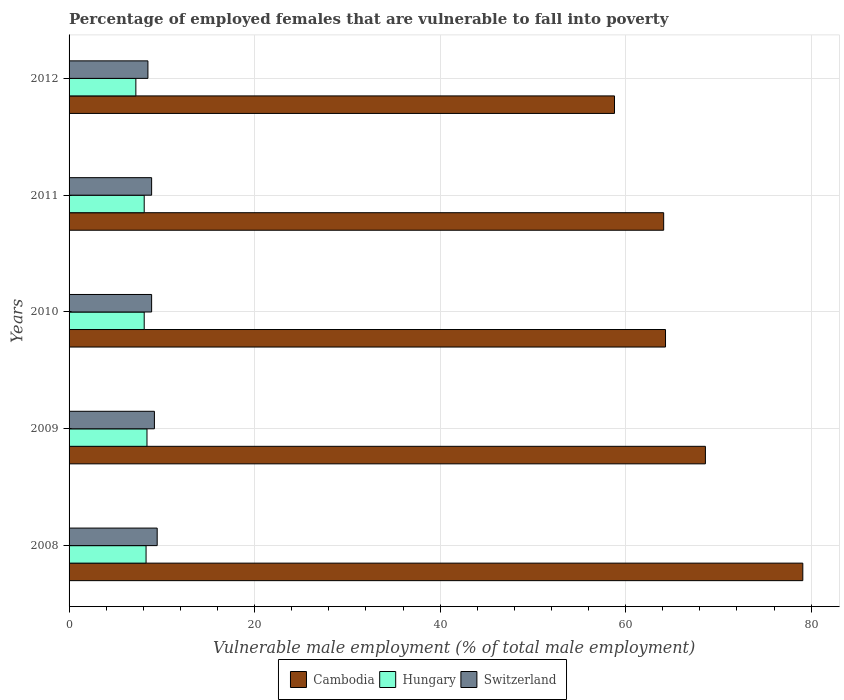How many groups of bars are there?
Provide a short and direct response. 5. How many bars are there on the 5th tick from the top?
Provide a succinct answer. 3. What is the label of the 5th group of bars from the top?
Offer a terse response. 2008. In how many cases, is the number of bars for a given year not equal to the number of legend labels?
Offer a very short reply. 0. What is the percentage of employed females who are vulnerable to fall into poverty in Cambodia in 2012?
Keep it short and to the point. 58.8. Across all years, what is the minimum percentage of employed females who are vulnerable to fall into poverty in Hungary?
Keep it short and to the point. 7.2. What is the total percentage of employed females who are vulnerable to fall into poverty in Switzerland in the graph?
Your answer should be compact. 45. What is the difference between the percentage of employed females who are vulnerable to fall into poverty in Hungary in 2008 and that in 2012?
Ensure brevity in your answer.  1.1. What is the difference between the percentage of employed females who are vulnerable to fall into poverty in Cambodia in 2009 and the percentage of employed females who are vulnerable to fall into poverty in Switzerland in 2012?
Offer a terse response. 60.1. What is the average percentage of employed females who are vulnerable to fall into poverty in Hungary per year?
Keep it short and to the point. 8.02. In the year 2012, what is the difference between the percentage of employed females who are vulnerable to fall into poverty in Cambodia and percentage of employed females who are vulnerable to fall into poverty in Hungary?
Offer a terse response. 51.6. In how many years, is the percentage of employed females who are vulnerable to fall into poverty in Cambodia greater than 16 %?
Ensure brevity in your answer.  5. What is the ratio of the percentage of employed females who are vulnerable to fall into poverty in Cambodia in 2011 to that in 2012?
Provide a short and direct response. 1.09. Is the percentage of employed females who are vulnerable to fall into poverty in Cambodia in 2009 less than that in 2010?
Your answer should be very brief. No. What is the difference between the highest and the second highest percentage of employed females who are vulnerable to fall into poverty in Switzerland?
Your answer should be compact. 0.3. In how many years, is the percentage of employed females who are vulnerable to fall into poverty in Hungary greater than the average percentage of employed females who are vulnerable to fall into poverty in Hungary taken over all years?
Provide a short and direct response. 4. Is the sum of the percentage of employed females who are vulnerable to fall into poverty in Cambodia in 2011 and 2012 greater than the maximum percentage of employed females who are vulnerable to fall into poverty in Switzerland across all years?
Your response must be concise. Yes. What does the 3rd bar from the top in 2011 represents?
Provide a succinct answer. Cambodia. What does the 1st bar from the bottom in 2009 represents?
Keep it short and to the point. Cambodia. How many bars are there?
Your response must be concise. 15. How many years are there in the graph?
Keep it short and to the point. 5. What is the difference between two consecutive major ticks on the X-axis?
Provide a succinct answer. 20. Are the values on the major ticks of X-axis written in scientific E-notation?
Keep it short and to the point. No. Does the graph contain any zero values?
Your response must be concise. No. Does the graph contain grids?
Ensure brevity in your answer.  Yes. Where does the legend appear in the graph?
Your response must be concise. Bottom center. How are the legend labels stacked?
Offer a very short reply. Horizontal. What is the title of the graph?
Ensure brevity in your answer.  Percentage of employed females that are vulnerable to fall into poverty. Does "Liechtenstein" appear as one of the legend labels in the graph?
Provide a succinct answer. No. What is the label or title of the X-axis?
Your answer should be compact. Vulnerable male employment (% of total male employment). What is the label or title of the Y-axis?
Keep it short and to the point. Years. What is the Vulnerable male employment (% of total male employment) of Cambodia in 2008?
Your answer should be compact. 79.1. What is the Vulnerable male employment (% of total male employment) in Hungary in 2008?
Give a very brief answer. 8.3. What is the Vulnerable male employment (% of total male employment) of Switzerland in 2008?
Give a very brief answer. 9.5. What is the Vulnerable male employment (% of total male employment) of Cambodia in 2009?
Offer a terse response. 68.6. What is the Vulnerable male employment (% of total male employment) of Hungary in 2009?
Provide a succinct answer. 8.4. What is the Vulnerable male employment (% of total male employment) of Switzerland in 2009?
Your answer should be very brief. 9.2. What is the Vulnerable male employment (% of total male employment) of Cambodia in 2010?
Give a very brief answer. 64.3. What is the Vulnerable male employment (% of total male employment) in Hungary in 2010?
Provide a succinct answer. 8.1. What is the Vulnerable male employment (% of total male employment) in Switzerland in 2010?
Offer a very short reply. 8.9. What is the Vulnerable male employment (% of total male employment) in Cambodia in 2011?
Make the answer very short. 64.1. What is the Vulnerable male employment (% of total male employment) in Hungary in 2011?
Make the answer very short. 8.1. What is the Vulnerable male employment (% of total male employment) in Switzerland in 2011?
Offer a terse response. 8.9. What is the Vulnerable male employment (% of total male employment) of Cambodia in 2012?
Your answer should be compact. 58.8. What is the Vulnerable male employment (% of total male employment) of Hungary in 2012?
Your answer should be compact. 7.2. Across all years, what is the maximum Vulnerable male employment (% of total male employment) in Cambodia?
Ensure brevity in your answer.  79.1. Across all years, what is the maximum Vulnerable male employment (% of total male employment) in Hungary?
Give a very brief answer. 8.4. Across all years, what is the maximum Vulnerable male employment (% of total male employment) of Switzerland?
Your answer should be compact. 9.5. Across all years, what is the minimum Vulnerable male employment (% of total male employment) of Cambodia?
Offer a very short reply. 58.8. Across all years, what is the minimum Vulnerable male employment (% of total male employment) in Hungary?
Give a very brief answer. 7.2. Across all years, what is the minimum Vulnerable male employment (% of total male employment) of Switzerland?
Provide a succinct answer. 8.5. What is the total Vulnerable male employment (% of total male employment) in Cambodia in the graph?
Offer a terse response. 334.9. What is the total Vulnerable male employment (% of total male employment) in Hungary in the graph?
Offer a very short reply. 40.1. What is the difference between the Vulnerable male employment (% of total male employment) in Switzerland in 2008 and that in 2009?
Keep it short and to the point. 0.3. What is the difference between the Vulnerable male employment (% of total male employment) of Cambodia in 2008 and that in 2010?
Your answer should be compact. 14.8. What is the difference between the Vulnerable male employment (% of total male employment) of Cambodia in 2008 and that in 2012?
Your answer should be compact. 20.3. What is the difference between the Vulnerable male employment (% of total male employment) in Hungary in 2008 and that in 2012?
Make the answer very short. 1.1. What is the difference between the Vulnerable male employment (% of total male employment) in Switzerland in 2008 and that in 2012?
Your answer should be very brief. 1. What is the difference between the Vulnerable male employment (% of total male employment) in Cambodia in 2009 and that in 2010?
Your answer should be compact. 4.3. What is the difference between the Vulnerable male employment (% of total male employment) in Cambodia in 2009 and that in 2011?
Give a very brief answer. 4.5. What is the difference between the Vulnerable male employment (% of total male employment) in Hungary in 2009 and that in 2011?
Ensure brevity in your answer.  0.3. What is the difference between the Vulnerable male employment (% of total male employment) in Cambodia in 2009 and that in 2012?
Offer a very short reply. 9.8. What is the difference between the Vulnerable male employment (% of total male employment) of Hungary in 2009 and that in 2012?
Keep it short and to the point. 1.2. What is the difference between the Vulnerable male employment (% of total male employment) of Switzerland in 2010 and that in 2011?
Provide a succinct answer. 0. What is the difference between the Vulnerable male employment (% of total male employment) in Hungary in 2010 and that in 2012?
Your answer should be very brief. 0.9. What is the difference between the Vulnerable male employment (% of total male employment) of Switzerland in 2010 and that in 2012?
Your answer should be compact. 0.4. What is the difference between the Vulnerable male employment (% of total male employment) in Hungary in 2011 and that in 2012?
Your response must be concise. 0.9. What is the difference between the Vulnerable male employment (% of total male employment) in Cambodia in 2008 and the Vulnerable male employment (% of total male employment) in Hungary in 2009?
Give a very brief answer. 70.7. What is the difference between the Vulnerable male employment (% of total male employment) of Cambodia in 2008 and the Vulnerable male employment (% of total male employment) of Switzerland in 2009?
Offer a terse response. 69.9. What is the difference between the Vulnerable male employment (% of total male employment) in Hungary in 2008 and the Vulnerable male employment (% of total male employment) in Switzerland in 2009?
Your answer should be compact. -0.9. What is the difference between the Vulnerable male employment (% of total male employment) of Cambodia in 2008 and the Vulnerable male employment (% of total male employment) of Switzerland in 2010?
Offer a terse response. 70.2. What is the difference between the Vulnerable male employment (% of total male employment) of Hungary in 2008 and the Vulnerable male employment (% of total male employment) of Switzerland in 2010?
Your answer should be very brief. -0.6. What is the difference between the Vulnerable male employment (% of total male employment) in Cambodia in 2008 and the Vulnerable male employment (% of total male employment) in Hungary in 2011?
Offer a terse response. 71. What is the difference between the Vulnerable male employment (% of total male employment) in Cambodia in 2008 and the Vulnerable male employment (% of total male employment) in Switzerland in 2011?
Your answer should be compact. 70.2. What is the difference between the Vulnerable male employment (% of total male employment) in Cambodia in 2008 and the Vulnerable male employment (% of total male employment) in Hungary in 2012?
Your answer should be very brief. 71.9. What is the difference between the Vulnerable male employment (% of total male employment) in Cambodia in 2008 and the Vulnerable male employment (% of total male employment) in Switzerland in 2012?
Provide a succinct answer. 70.6. What is the difference between the Vulnerable male employment (% of total male employment) in Hungary in 2008 and the Vulnerable male employment (% of total male employment) in Switzerland in 2012?
Provide a succinct answer. -0.2. What is the difference between the Vulnerable male employment (% of total male employment) of Cambodia in 2009 and the Vulnerable male employment (% of total male employment) of Hungary in 2010?
Your response must be concise. 60.5. What is the difference between the Vulnerable male employment (% of total male employment) of Cambodia in 2009 and the Vulnerable male employment (% of total male employment) of Switzerland in 2010?
Offer a very short reply. 59.7. What is the difference between the Vulnerable male employment (% of total male employment) in Cambodia in 2009 and the Vulnerable male employment (% of total male employment) in Hungary in 2011?
Provide a succinct answer. 60.5. What is the difference between the Vulnerable male employment (% of total male employment) of Cambodia in 2009 and the Vulnerable male employment (% of total male employment) of Switzerland in 2011?
Your response must be concise. 59.7. What is the difference between the Vulnerable male employment (% of total male employment) in Hungary in 2009 and the Vulnerable male employment (% of total male employment) in Switzerland in 2011?
Your response must be concise. -0.5. What is the difference between the Vulnerable male employment (% of total male employment) in Cambodia in 2009 and the Vulnerable male employment (% of total male employment) in Hungary in 2012?
Ensure brevity in your answer.  61.4. What is the difference between the Vulnerable male employment (% of total male employment) of Cambodia in 2009 and the Vulnerable male employment (% of total male employment) of Switzerland in 2012?
Offer a very short reply. 60.1. What is the difference between the Vulnerable male employment (% of total male employment) of Hungary in 2009 and the Vulnerable male employment (% of total male employment) of Switzerland in 2012?
Make the answer very short. -0.1. What is the difference between the Vulnerable male employment (% of total male employment) in Cambodia in 2010 and the Vulnerable male employment (% of total male employment) in Hungary in 2011?
Ensure brevity in your answer.  56.2. What is the difference between the Vulnerable male employment (% of total male employment) in Cambodia in 2010 and the Vulnerable male employment (% of total male employment) in Switzerland in 2011?
Ensure brevity in your answer.  55.4. What is the difference between the Vulnerable male employment (% of total male employment) in Hungary in 2010 and the Vulnerable male employment (% of total male employment) in Switzerland in 2011?
Your answer should be very brief. -0.8. What is the difference between the Vulnerable male employment (% of total male employment) of Cambodia in 2010 and the Vulnerable male employment (% of total male employment) of Hungary in 2012?
Your answer should be compact. 57.1. What is the difference between the Vulnerable male employment (% of total male employment) in Cambodia in 2010 and the Vulnerable male employment (% of total male employment) in Switzerland in 2012?
Offer a very short reply. 55.8. What is the difference between the Vulnerable male employment (% of total male employment) in Hungary in 2010 and the Vulnerable male employment (% of total male employment) in Switzerland in 2012?
Make the answer very short. -0.4. What is the difference between the Vulnerable male employment (% of total male employment) in Cambodia in 2011 and the Vulnerable male employment (% of total male employment) in Hungary in 2012?
Your answer should be very brief. 56.9. What is the difference between the Vulnerable male employment (% of total male employment) in Cambodia in 2011 and the Vulnerable male employment (% of total male employment) in Switzerland in 2012?
Keep it short and to the point. 55.6. What is the average Vulnerable male employment (% of total male employment) in Cambodia per year?
Ensure brevity in your answer.  66.98. What is the average Vulnerable male employment (% of total male employment) in Hungary per year?
Keep it short and to the point. 8.02. In the year 2008, what is the difference between the Vulnerable male employment (% of total male employment) of Cambodia and Vulnerable male employment (% of total male employment) of Hungary?
Keep it short and to the point. 70.8. In the year 2008, what is the difference between the Vulnerable male employment (% of total male employment) in Cambodia and Vulnerable male employment (% of total male employment) in Switzerland?
Your answer should be compact. 69.6. In the year 2008, what is the difference between the Vulnerable male employment (% of total male employment) of Hungary and Vulnerable male employment (% of total male employment) of Switzerland?
Provide a short and direct response. -1.2. In the year 2009, what is the difference between the Vulnerable male employment (% of total male employment) in Cambodia and Vulnerable male employment (% of total male employment) in Hungary?
Give a very brief answer. 60.2. In the year 2009, what is the difference between the Vulnerable male employment (% of total male employment) of Cambodia and Vulnerable male employment (% of total male employment) of Switzerland?
Make the answer very short. 59.4. In the year 2009, what is the difference between the Vulnerable male employment (% of total male employment) of Hungary and Vulnerable male employment (% of total male employment) of Switzerland?
Provide a short and direct response. -0.8. In the year 2010, what is the difference between the Vulnerable male employment (% of total male employment) in Cambodia and Vulnerable male employment (% of total male employment) in Hungary?
Keep it short and to the point. 56.2. In the year 2010, what is the difference between the Vulnerable male employment (% of total male employment) of Cambodia and Vulnerable male employment (% of total male employment) of Switzerland?
Give a very brief answer. 55.4. In the year 2010, what is the difference between the Vulnerable male employment (% of total male employment) in Hungary and Vulnerable male employment (% of total male employment) in Switzerland?
Offer a very short reply. -0.8. In the year 2011, what is the difference between the Vulnerable male employment (% of total male employment) in Cambodia and Vulnerable male employment (% of total male employment) in Switzerland?
Keep it short and to the point. 55.2. In the year 2012, what is the difference between the Vulnerable male employment (% of total male employment) in Cambodia and Vulnerable male employment (% of total male employment) in Hungary?
Offer a very short reply. 51.6. In the year 2012, what is the difference between the Vulnerable male employment (% of total male employment) of Cambodia and Vulnerable male employment (% of total male employment) of Switzerland?
Offer a very short reply. 50.3. In the year 2012, what is the difference between the Vulnerable male employment (% of total male employment) of Hungary and Vulnerable male employment (% of total male employment) of Switzerland?
Provide a short and direct response. -1.3. What is the ratio of the Vulnerable male employment (% of total male employment) in Cambodia in 2008 to that in 2009?
Offer a terse response. 1.15. What is the ratio of the Vulnerable male employment (% of total male employment) of Hungary in 2008 to that in 2009?
Provide a short and direct response. 0.99. What is the ratio of the Vulnerable male employment (% of total male employment) in Switzerland in 2008 to that in 2009?
Your answer should be compact. 1.03. What is the ratio of the Vulnerable male employment (% of total male employment) of Cambodia in 2008 to that in 2010?
Your answer should be very brief. 1.23. What is the ratio of the Vulnerable male employment (% of total male employment) of Hungary in 2008 to that in 2010?
Offer a very short reply. 1.02. What is the ratio of the Vulnerable male employment (% of total male employment) in Switzerland in 2008 to that in 2010?
Your response must be concise. 1.07. What is the ratio of the Vulnerable male employment (% of total male employment) of Cambodia in 2008 to that in 2011?
Keep it short and to the point. 1.23. What is the ratio of the Vulnerable male employment (% of total male employment) in Hungary in 2008 to that in 2011?
Ensure brevity in your answer.  1.02. What is the ratio of the Vulnerable male employment (% of total male employment) of Switzerland in 2008 to that in 2011?
Your answer should be very brief. 1.07. What is the ratio of the Vulnerable male employment (% of total male employment) in Cambodia in 2008 to that in 2012?
Provide a short and direct response. 1.35. What is the ratio of the Vulnerable male employment (% of total male employment) of Hungary in 2008 to that in 2012?
Provide a short and direct response. 1.15. What is the ratio of the Vulnerable male employment (% of total male employment) of Switzerland in 2008 to that in 2012?
Offer a very short reply. 1.12. What is the ratio of the Vulnerable male employment (% of total male employment) of Cambodia in 2009 to that in 2010?
Offer a terse response. 1.07. What is the ratio of the Vulnerable male employment (% of total male employment) of Switzerland in 2009 to that in 2010?
Your response must be concise. 1.03. What is the ratio of the Vulnerable male employment (% of total male employment) in Cambodia in 2009 to that in 2011?
Provide a short and direct response. 1.07. What is the ratio of the Vulnerable male employment (% of total male employment) in Hungary in 2009 to that in 2011?
Your answer should be very brief. 1.04. What is the ratio of the Vulnerable male employment (% of total male employment) in Switzerland in 2009 to that in 2011?
Ensure brevity in your answer.  1.03. What is the ratio of the Vulnerable male employment (% of total male employment) of Cambodia in 2009 to that in 2012?
Your answer should be very brief. 1.17. What is the ratio of the Vulnerable male employment (% of total male employment) in Hungary in 2009 to that in 2012?
Provide a succinct answer. 1.17. What is the ratio of the Vulnerable male employment (% of total male employment) of Switzerland in 2009 to that in 2012?
Keep it short and to the point. 1.08. What is the ratio of the Vulnerable male employment (% of total male employment) of Switzerland in 2010 to that in 2011?
Your answer should be very brief. 1. What is the ratio of the Vulnerable male employment (% of total male employment) of Cambodia in 2010 to that in 2012?
Provide a succinct answer. 1.09. What is the ratio of the Vulnerable male employment (% of total male employment) in Switzerland in 2010 to that in 2012?
Your response must be concise. 1.05. What is the ratio of the Vulnerable male employment (% of total male employment) in Cambodia in 2011 to that in 2012?
Offer a terse response. 1.09. What is the ratio of the Vulnerable male employment (% of total male employment) of Hungary in 2011 to that in 2012?
Provide a succinct answer. 1.12. What is the ratio of the Vulnerable male employment (% of total male employment) of Switzerland in 2011 to that in 2012?
Keep it short and to the point. 1.05. What is the difference between the highest and the second highest Vulnerable male employment (% of total male employment) of Hungary?
Ensure brevity in your answer.  0.1. What is the difference between the highest and the lowest Vulnerable male employment (% of total male employment) in Cambodia?
Your response must be concise. 20.3. What is the difference between the highest and the lowest Vulnerable male employment (% of total male employment) in Switzerland?
Your answer should be very brief. 1. 